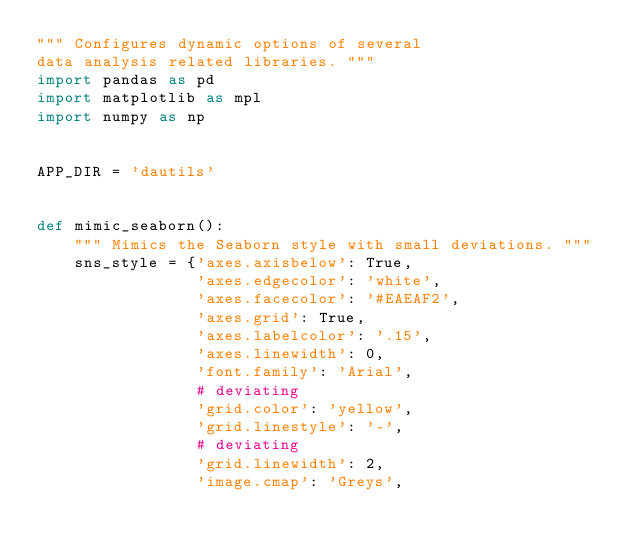Convert code to text. <code><loc_0><loc_0><loc_500><loc_500><_Python_>""" Configures dynamic options of several
data analysis related libraries. """
import pandas as pd
import matplotlib as mpl
import numpy as np


APP_DIR = 'dautils'


def mimic_seaborn():
    """ Mimics the Seaborn style with small deviations. """
    sns_style = {'axes.axisbelow': True,
                 'axes.edgecolor': 'white',
                 'axes.facecolor': '#EAEAF2',
                 'axes.grid': True,
                 'axes.labelcolor': '.15',
                 'axes.linewidth': 0,
                 'font.family': 'Arial',
                 # deviating
                 'grid.color': 'yellow',
                 'grid.linestyle': '-',
                 # deviating
                 'grid.linewidth': 2,
                 'image.cmap': 'Greys',</code> 